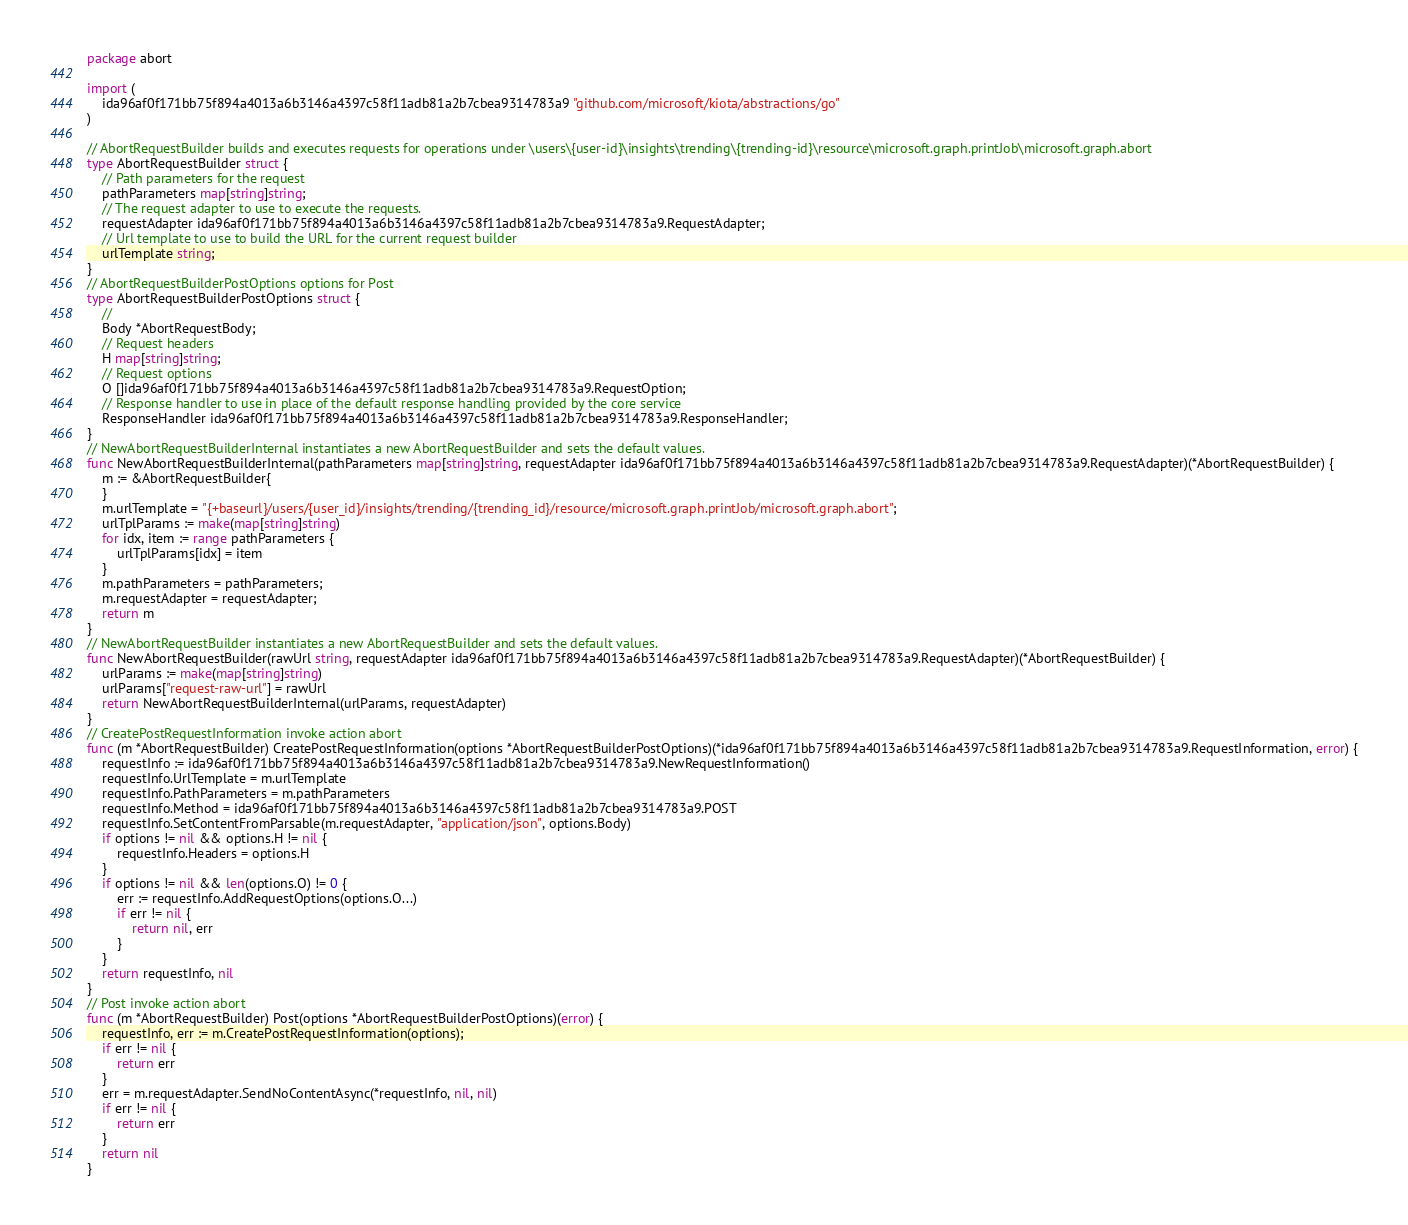<code> <loc_0><loc_0><loc_500><loc_500><_Go_>package abort

import (
    ida96af0f171bb75f894a4013a6b3146a4397c58f11adb81a2b7cbea9314783a9 "github.com/microsoft/kiota/abstractions/go"
)

// AbortRequestBuilder builds and executes requests for operations under \users\{user-id}\insights\trending\{trending-id}\resource\microsoft.graph.printJob\microsoft.graph.abort
type AbortRequestBuilder struct {
    // Path parameters for the request
    pathParameters map[string]string;
    // The request adapter to use to execute the requests.
    requestAdapter ida96af0f171bb75f894a4013a6b3146a4397c58f11adb81a2b7cbea9314783a9.RequestAdapter;
    // Url template to use to build the URL for the current request builder
    urlTemplate string;
}
// AbortRequestBuilderPostOptions options for Post
type AbortRequestBuilderPostOptions struct {
    // 
    Body *AbortRequestBody;
    // Request headers
    H map[string]string;
    // Request options
    O []ida96af0f171bb75f894a4013a6b3146a4397c58f11adb81a2b7cbea9314783a9.RequestOption;
    // Response handler to use in place of the default response handling provided by the core service
    ResponseHandler ida96af0f171bb75f894a4013a6b3146a4397c58f11adb81a2b7cbea9314783a9.ResponseHandler;
}
// NewAbortRequestBuilderInternal instantiates a new AbortRequestBuilder and sets the default values.
func NewAbortRequestBuilderInternal(pathParameters map[string]string, requestAdapter ida96af0f171bb75f894a4013a6b3146a4397c58f11adb81a2b7cbea9314783a9.RequestAdapter)(*AbortRequestBuilder) {
    m := &AbortRequestBuilder{
    }
    m.urlTemplate = "{+baseurl}/users/{user_id}/insights/trending/{trending_id}/resource/microsoft.graph.printJob/microsoft.graph.abort";
    urlTplParams := make(map[string]string)
    for idx, item := range pathParameters {
        urlTplParams[idx] = item
    }
    m.pathParameters = pathParameters;
    m.requestAdapter = requestAdapter;
    return m
}
// NewAbortRequestBuilder instantiates a new AbortRequestBuilder and sets the default values.
func NewAbortRequestBuilder(rawUrl string, requestAdapter ida96af0f171bb75f894a4013a6b3146a4397c58f11adb81a2b7cbea9314783a9.RequestAdapter)(*AbortRequestBuilder) {
    urlParams := make(map[string]string)
    urlParams["request-raw-url"] = rawUrl
    return NewAbortRequestBuilderInternal(urlParams, requestAdapter)
}
// CreatePostRequestInformation invoke action abort
func (m *AbortRequestBuilder) CreatePostRequestInformation(options *AbortRequestBuilderPostOptions)(*ida96af0f171bb75f894a4013a6b3146a4397c58f11adb81a2b7cbea9314783a9.RequestInformation, error) {
    requestInfo := ida96af0f171bb75f894a4013a6b3146a4397c58f11adb81a2b7cbea9314783a9.NewRequestInformation()
    requestInfo.UrlTemplate = m.urlTemplate
    requestInfo.PathParameters = m.pathParameters
    requestInfo.Method = ida96af0f171bb75f894a4013a6b3146a4397c58f11adb81a2b7cbea9314783a9.POST
    requestInfo.SetContentFromParsable(m.requestAdapter, "application/json", options.Body)
    if options != nil && options.H != nil {
        requestInfo.Headers = options.H
    }
    if options != nil && len(options.O) != 0 {
        err := requestInfo.AddRequestOptions(options.O...)
        if err != nil {
            return nil, err
        }
    }
    return requestInfo, nil
}
// Post invoke action abort
func (m *AbortRequestBuilder) Post(options *AbortRequestBuilderPostOptions)(error) {
    requestInfo, err := m.CreatePostRequestInformation(options);
    if err != nil {
        return err
    }
    err = m.requestAdapter.SendNoContentAsync(*requestInfo, nil, nil)
    if err != nil {
        return err
    }
    return nil
}
</code> 